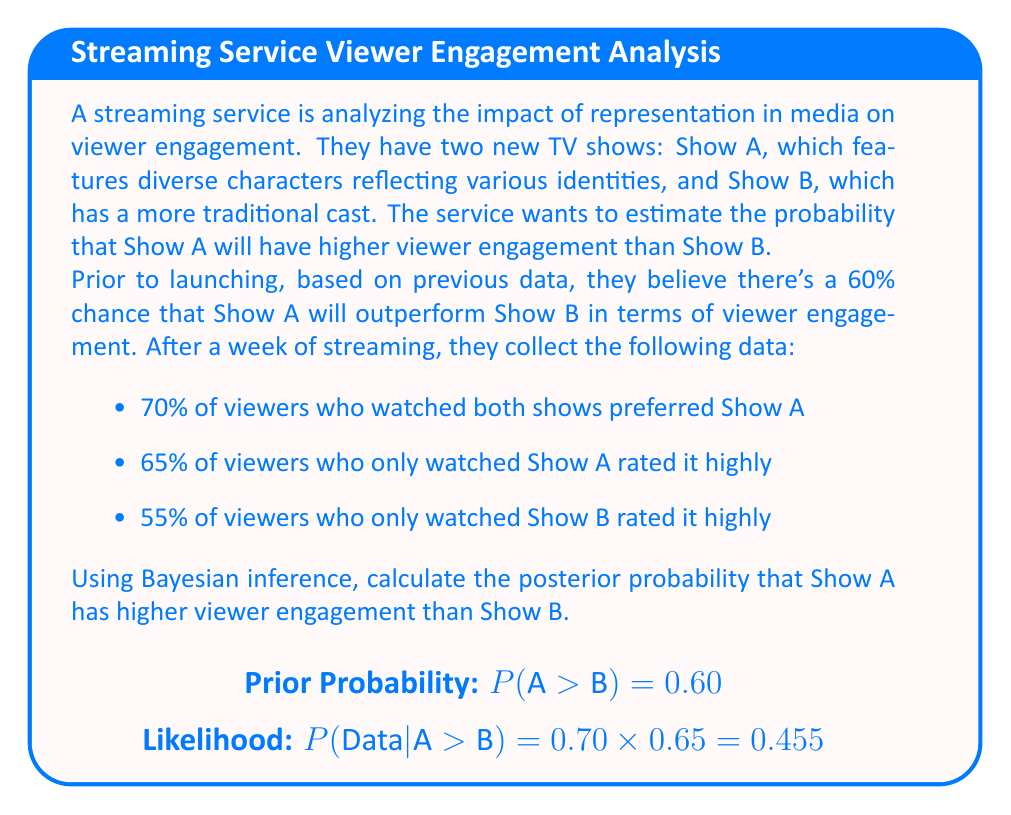Teach me how to tackle this problem. Let's approach this step-by-step using Bayesian inference:

1) Define our events:
   H: Show A has higher viewer engagement than Show B
   D: The observed data

2) We're given the prior probability:
   P(H) = 0.60

3) We need to calculate P(H|D) using Bayes' theorem:

   $$P(H|D) = \frac{P(D|H) \cdot P(H)}{P(D)}$$

4) Calculate P(D|H), the likelihood of observing the data given that H is true:
   
   $$P(D|H) = 0.70 \cdot 0.65 \cdot (1 - 0.55) = 0.70 \cdot 0.65 \cdot 0.45 = 0.20475$$

5) Calculate P(D|not H), the likelihood of observing the data given that H is false:
   
   $$P(D|\text{not }H) = 0.30 \cdot 0.35 \cdot 0.55 = 0.05775$$

6) Calculate P(D) using the law of total probability:
   
   $$P(D) = P(D|H) \cdot P(H) + P(D|\text{not }H) \cdot P(\text{not }H)$$
   $$P(D) = 0.20475 \cdot 0.60 + 0.05775 \cdot 0.40 = 0.12285 + 0.0231 = 0.14595$$

7) Now we can calculate the posterior probability:

   $$P(H|D) = \frac{0.20475 \cdot 0.60}{0.14595} \approx 0.8415$$

Therefore, the posterior probability that Show A has higher viewer engagement than Show B is approximately 0.8415 or 84.15%.
Answer: 0.8415 